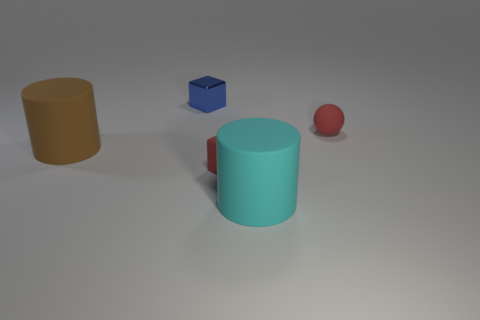Add 4 big blue matte cylinders. How many objects exist? 9 Subtract all cylinders. How many objects are left? 3 Subtract 1 cyan cylinders. How many objects are left? 4 Subtract all big cylinders. Subtract all blue metal things. How many objects are left? 2 Add 3 tiny objects. How many tiny objects are left? 6 Add 5 rubber blocks. How many rubber blocks exist? 6 